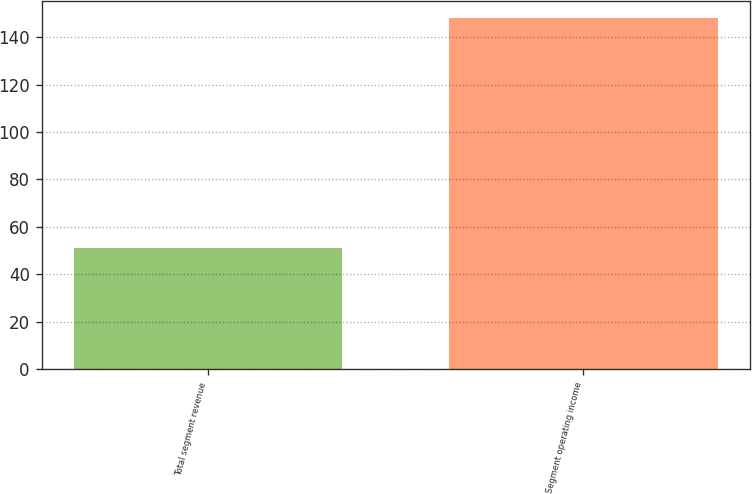Convert chart. <chart><loc_0><loc_0><loc_500><loc_500><bar_chart><fcel>Total segment revenue<fcel>Segment operating income<nl><fcel>51<fcel>148<nl></chart> 